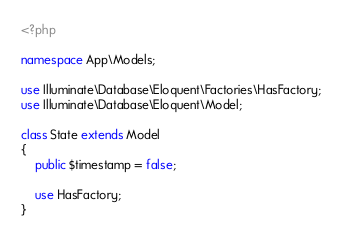<code> <loc_0><loc_0><loc_500><loc_500><_PHP_><?php

namespace App\Models;

use Illuminate\Database\Eloquent\Factories\HasFactory;
use Illuminate\Database\Eloquent\Model;

class State extends Model
{
    public $timestamp = false;

    use HasFactory;
}
</code> 